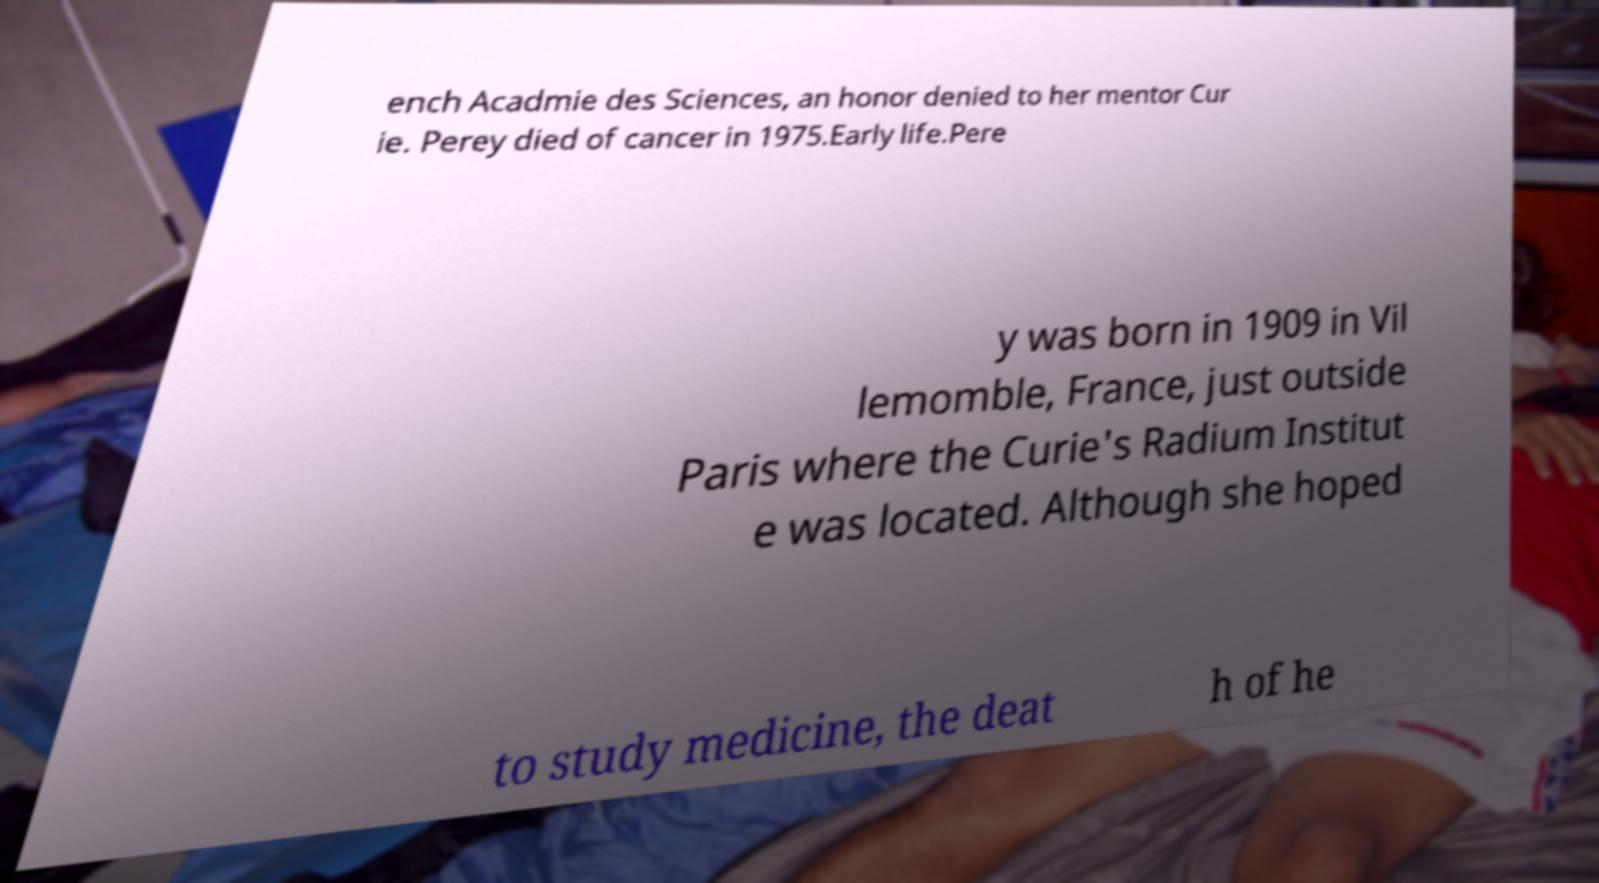Could you assist in decoding the text presented in this image and type it out clearly? ench Acadmie des Sciences, an honor denied to her mentor Cur ie. Perey died of cancer in 1975.Early life.Pere y was born in 1909 in Vil lemomble, France, just outside Paris where the Curie's Radium Institut e was located. Although she hoped to study medicine, the deat h of he 